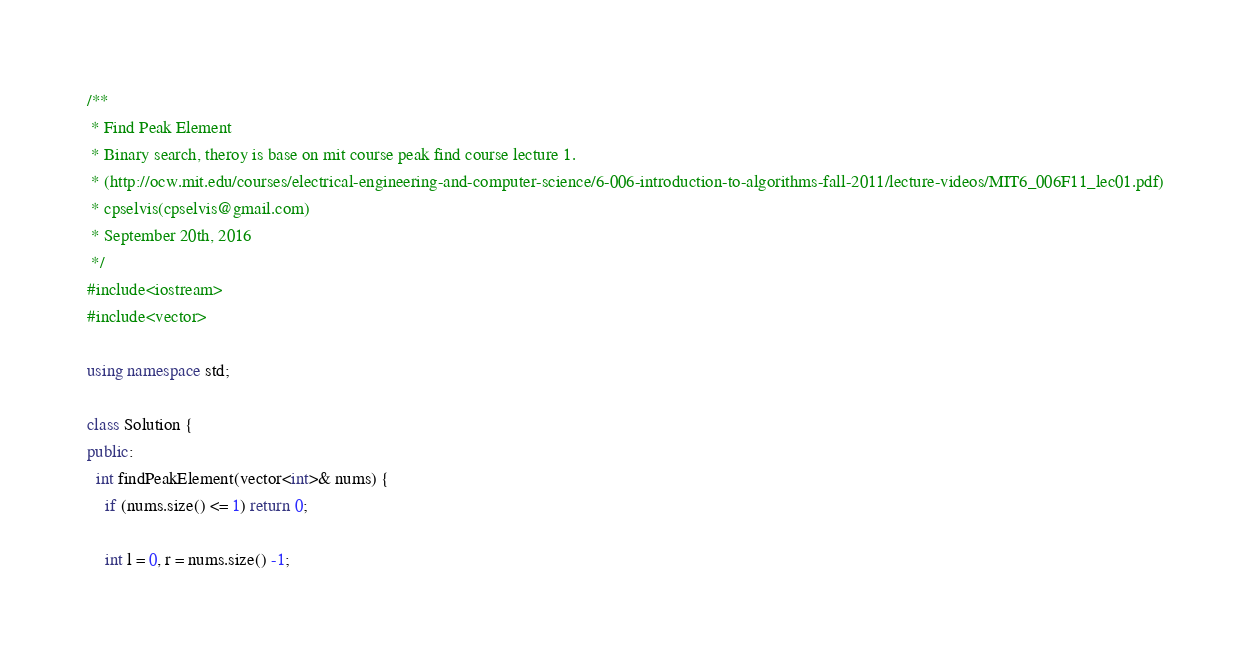Convert code to text. <code><loc_0><loc_0><loc_500><loc_500><_C++_>/**
 * Find Peak Element
 * Binary search, theroy is base on mit course peak find course lecture 1.
 * (http://ocw.mit.edu/courses/electrical-engineering-and-computer-science/6-006-introduction-to-algorithms-fall-2011/lecture-videos/MIT6_006F11_lec01.pdf)
 * cpselvis(cpselvis@gmail.com)
 * September 20th, 2016
 */
#include<iostream>
#include<vector>

using namespace std;

class Solution {
public:
  int findPeakElement(vector<int>& nums) {
    if (nums.size() <= 1) return 0;
    
    int l = 0, r = nums.size() -1;
</code> 